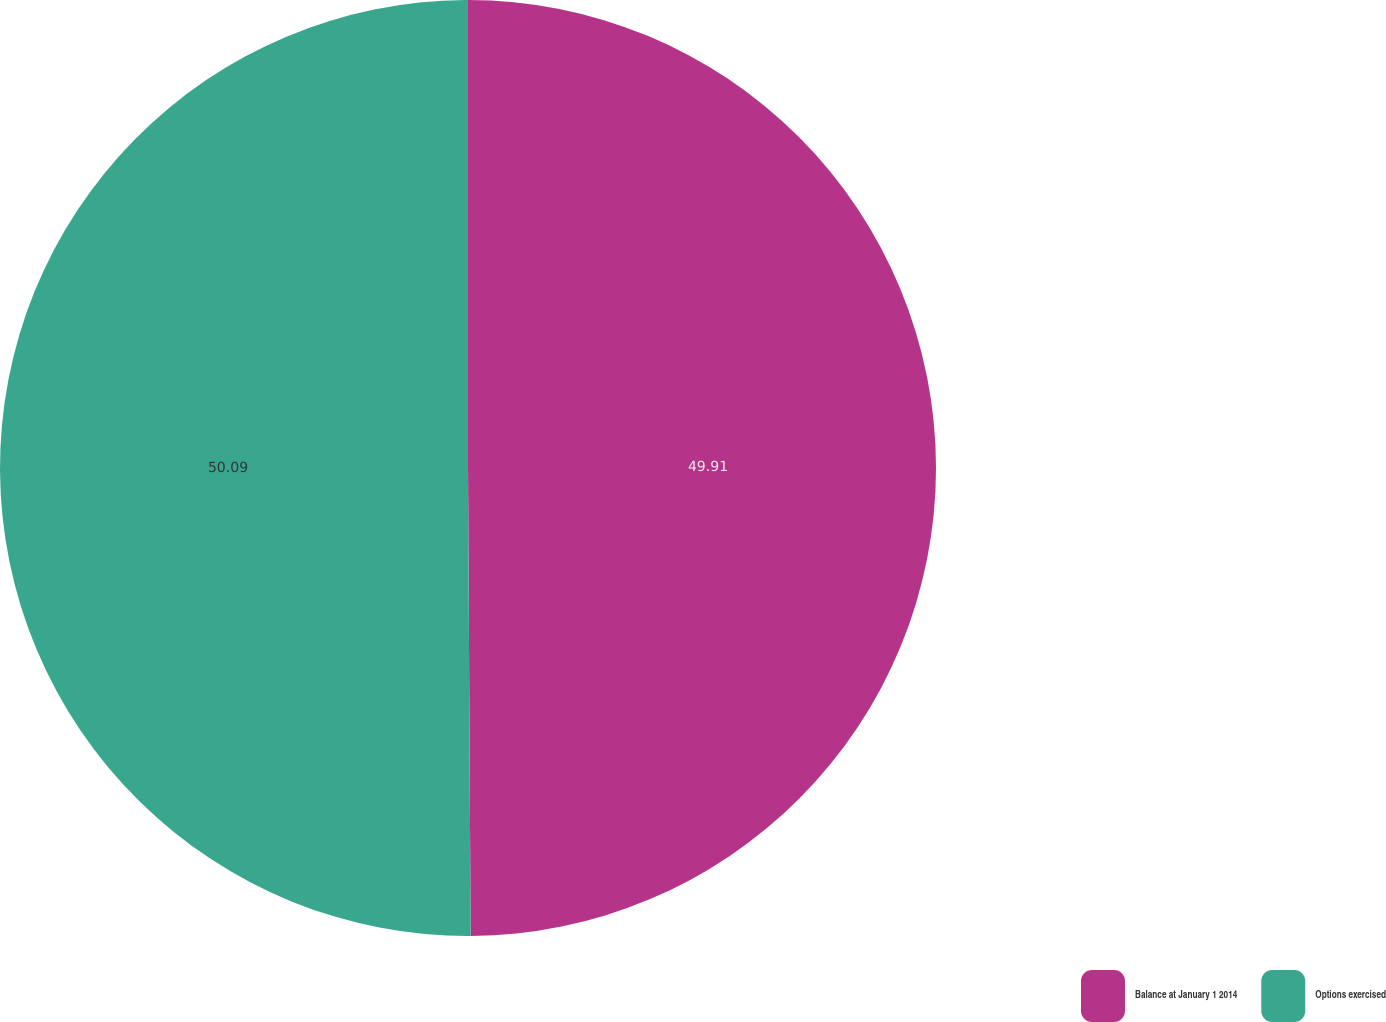<chart> <loc_0><loc_0><loc_500><loc_500><pie_chart><fcel>Balance at January 1 2014<fcel>Options exercised<nl><fcel>49.91%<fcel>50.09%<nl></chart> 